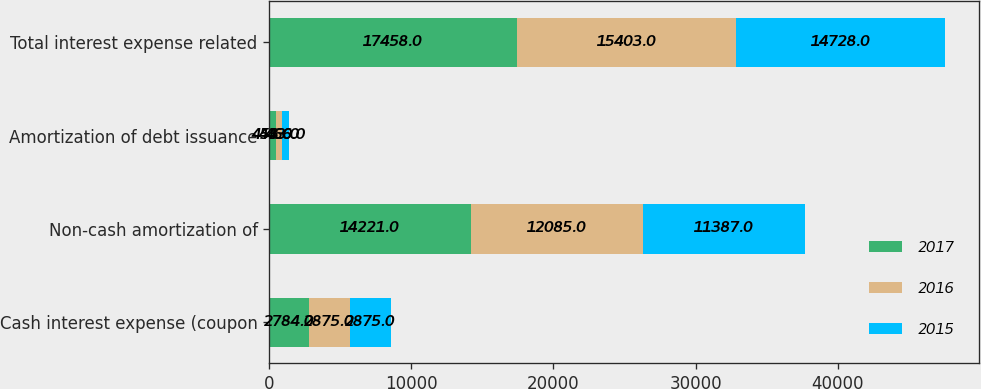Convert chart to OTSL. <chart><loc_0><loc_0><loc_500><loc_500><stacked_bar_chart><ecel><fcel>Cash interest expense (coupon<fcel>Non-cash amortization of<fcel>Amortization of debt issuance<fcel>Total interest expense related<nl><fcel>2017<fcel>2784<fcel>14221<fcel>453<fcel>17458<nl><fcel>2016<fcel>2875<fcel>12085<fcel>443<fcel>15403<nl><fcel>2015<fcel>2875<fcel>11387<fcel>466<fcel>14728<nl></chart> 